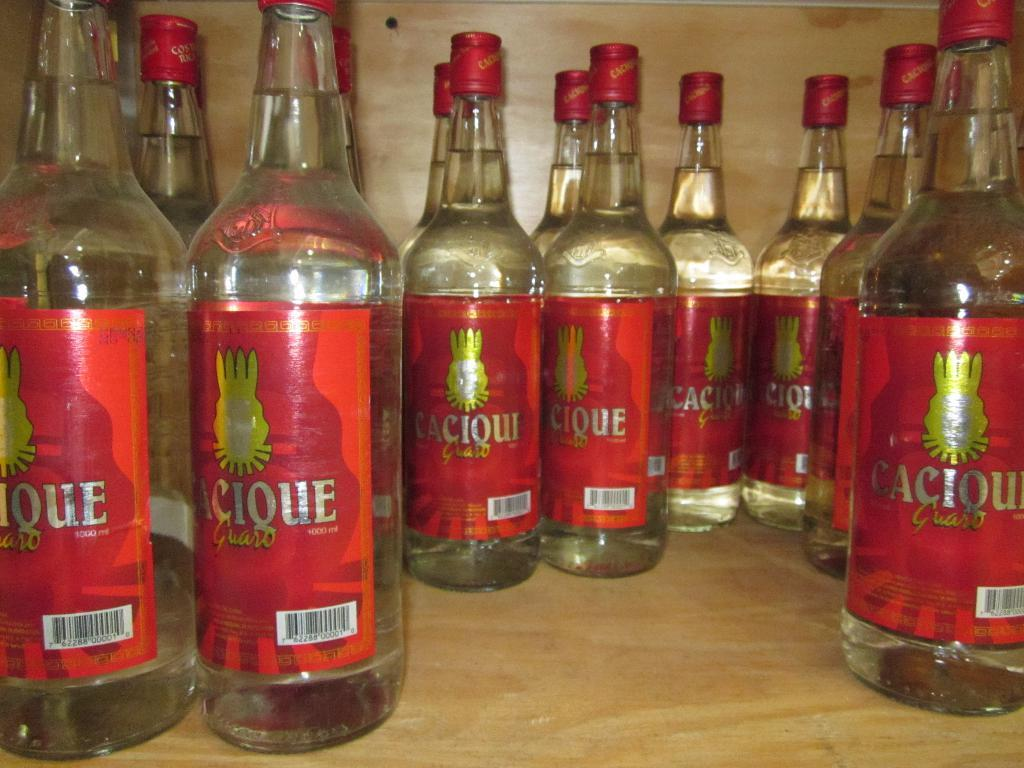What objects are in the image? There are bottles in the image. Where are the bottles located? The bottles are placed on a table. What can be observed about the bottles' condition? The bottles have a tight seal on them. How many people are smiling in the image? There are no people present in the image, so it is not possible to determine how many people might be smiling. 